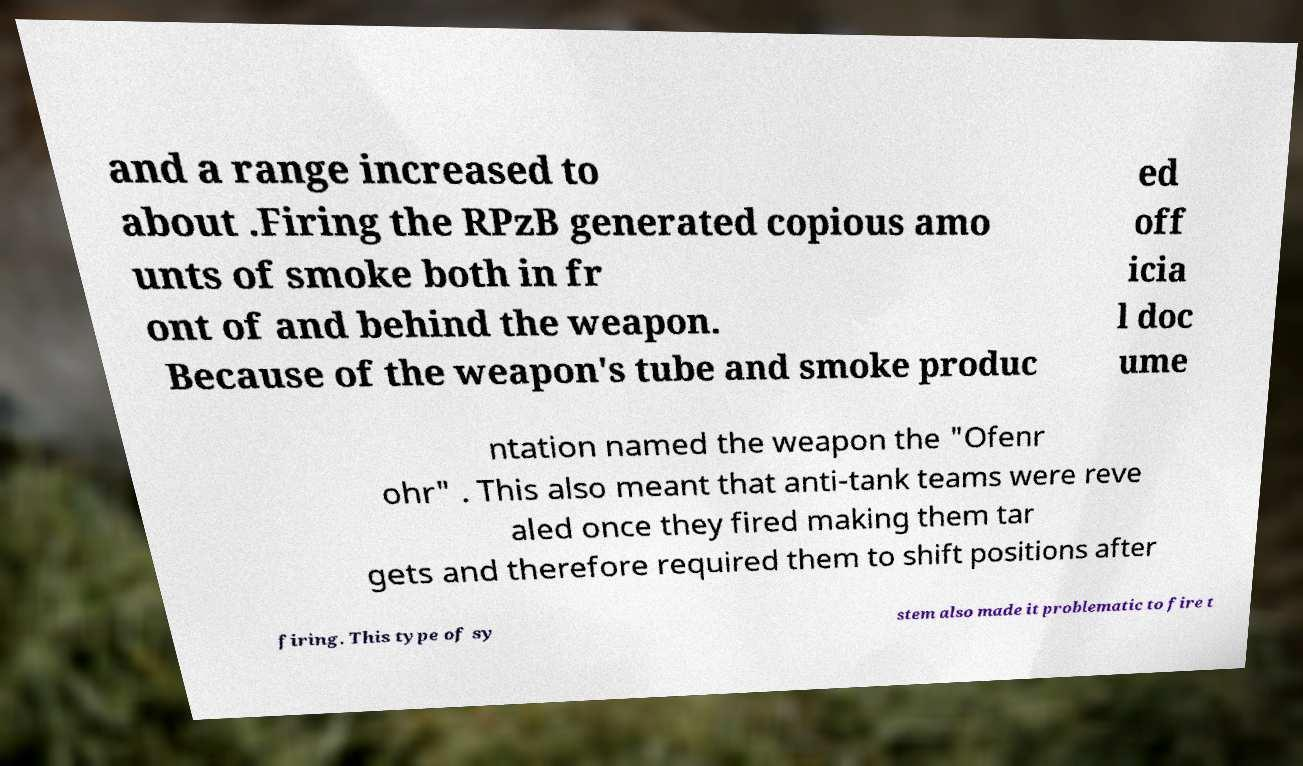I need the written content from this picture converted into text. Can you do that? and a range increased to about .Firing the RPzB generated copious amo unts of smoke both in fr ont of and behind the weapon. Because of the weapon's tube and smoke produc ed off icia l doc ume ntation named the weapon the "Ofenr ohr" . This also meant that anti-tank teams were reve aled once they fired making them tar gets and therefore required them to shift positions after firing. This type of sy stem also made it problematic to fire t 